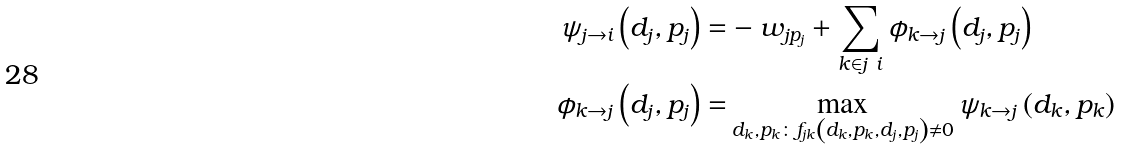<formula> <loc_0><loc_0><loc_500><loc_500>\psi _ { j \to i } \left ( d _ { j } , p _ { j } \right ) = & - w _ { j p _ { j } } + \sum _ { k \in j \ i } \phi _ { k \to j } \left ( d _ { j } , p _ { j } \right ) \\ \phi _ { k \to j } \left ( d _ { j } , p _ { j } \right ) = & \max _ { d _ { k } , p _ { k } \colon f _ { j k } \left ( d _ { k } , p _ { k } , d _ { j } , p _ { j } \right ) \neq 0 } \psi _ { k \to j } \left ( d _ { k } , p _ { k } \right )</formula> 